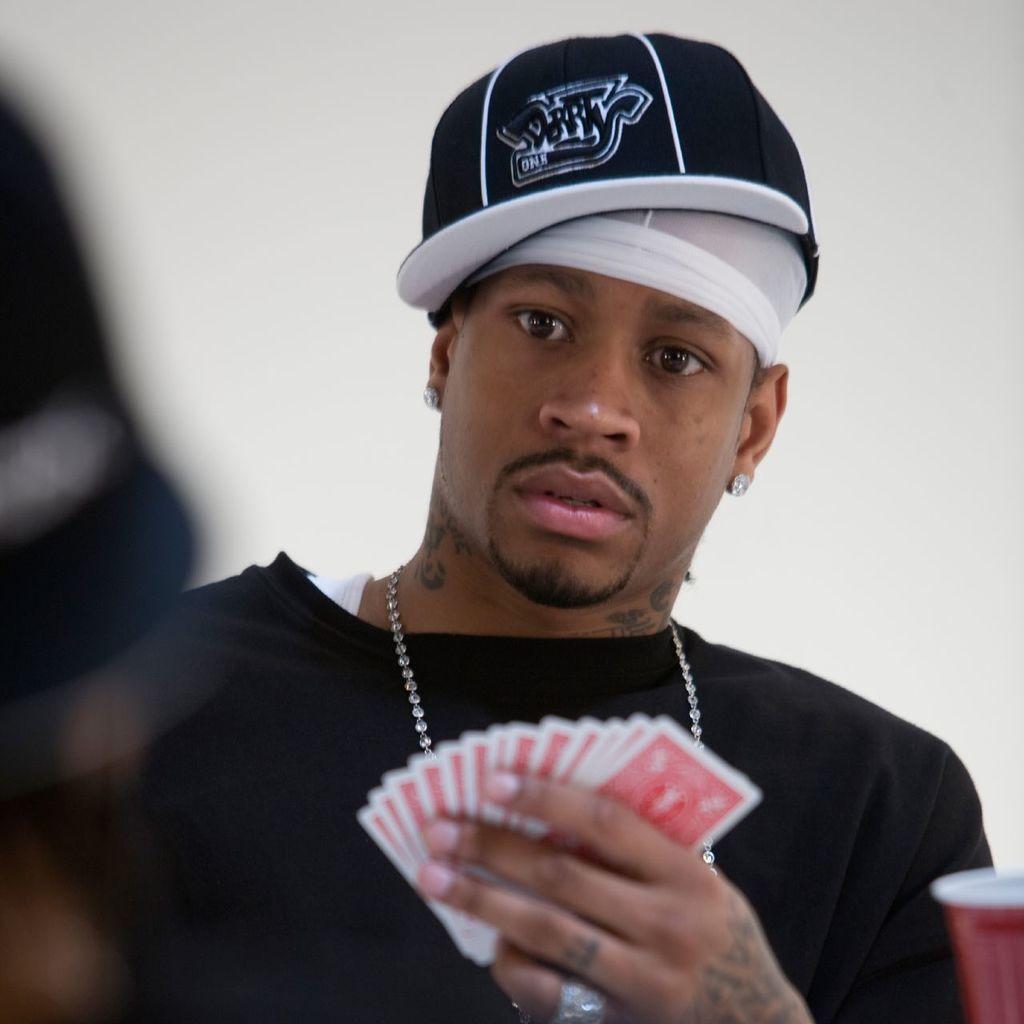How would you summarize this image in a sentence or two? In this image we can see a person wearing black color T-shirt and cap holding cards in his hands and in the background of the image there is a wall. 